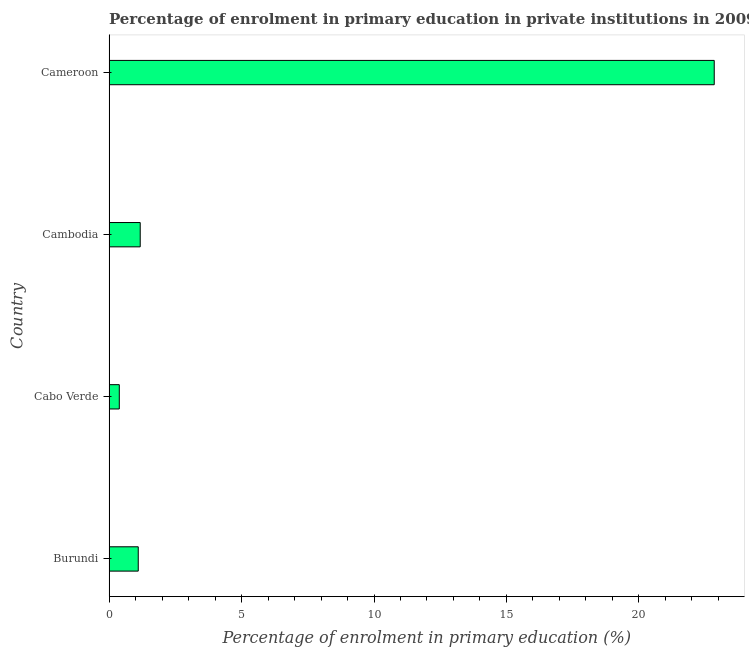Does the graph contain grids?
Ensure brevity in your answer.  No. What is the title of the graph?
Your answer should be very brief. Percentage of enrolment in primary education in private institutions in 2009. What is the label or title of the X-axis?
Keep it short and to the point. Percentage of enrolment in primary education (%). What is the label or title of the Y-axis?
Provide a short and direct response. Country. What is the enrolment percentage in primary education in Burundi?
Your response must be concise. 1.1. Across all countries, what is the maximum enrolment percentage in primary education?
Give a very brief answer. 22.84. Across all countries, what is the minimum enrolment percentage in primary education?
Ensure brevity in your answer.  0.39. In which country was the enrolment percentage in primary education maximum?
Make the answer very short. Cameroon. In which country was the enrolment percentage in primary education minimum?
Keep it short and to the point. Cabo Verde. What is the sum of the enrolment percentage in primary education?
Your response must be concise. 25.51. What is the difference between the enrolment percentage in primary education in Cabo Verde and Cambodia?
Give a very brief answer. -0.79. What is the average enrolment percentage in primary education per country?
Offer a terse response. 6.38. What is the median enrolment percentage in primary education?
Your answer should be compact. 1.14. What is the ratio of the enrolment percentage in primary education in Burundi to that in Cambodia?
Offer a very short reply. 0.94. Is the enrolment percentage in primary education in Burundi less than that in Cameroon?
Offer a very short reply. Yes. Is the difference between the enrolment percentage in primary education in Burundi and Cameroon greater than the difference between any two countries?
Offer a terse response. No. What is the difference between the highest and the second highest enrolment percentage in primary education?
Keep it short and to the point. 21.67. What is the difference between the highest and the lowest enrolment percentage in primary education?
Provide a succinct answer. 22.46. What is the Percentage of enrolment in primary education (%) of Burundi?
Your answer should be very brief. 1.1. What is the Percentage of enrolment in primary education (%) in Cabo Verde?
Your answer should be compact. 0.39. What is the Percentage of enrolment in primary education (%) of Cambodia?
Make the answer very short. 1.18. What is the Percentage of enrolment in primary education (%) of Cameroon?
Give a very brief answer. 22.84. What is the difference between the Percentage of enrolment in primary education (%) in Burundi and Cabo Verde?
Provide a short and direct response. 0.72. What is the difference between the Percentage of enrolment in primary education (%) in Burundi and Cambodia?
Your response must be concise. -0.07. What is the difference between the Percentage of enrolment in primary education (%) in Burundi and Cameroon?
Provide a succinct answer. -21.74. What is the difference between the Percentage of enrolment in primary education (%) in Cabo Verde and Cambodia?
Your response must be concise. -0.79. What is the difference between the Percentage of enrolment in primary education (%) in Cabo Verde and Cameroon?
Provide a short and direct response. -22.46. What is the difference between the Percentage of enrolment in primary education (%) in Cambodia and Cameroon?
Offer a very short reply. -21.67. What is the ratio of the Percentage of enrolment in primary education (%) in Burundi to that in Cabo Verde?
Your response must be concise. 2.85. What is the ratio of the Percentage of enrolment in primary education (%) in Burundi to that in Cambodia?
Provide a succinct answer. 0.94. What is the ratio of the Percentage of enrolment in primary education (%) in Burundi to that in Cameroon?
Your response must be concise. 0.05. What is the ratio of the Percentage of enrolment in primary education (%) in Cabo Verde to that in Cambodia?
Keep it short and to the point. 0.33. What is the ratio of the Percentage of enrolment in primary education (%) in Cabo Verde to that in Cameroon?
Provide a short and direct response. 0.02. What is the ratio of the Percentage of enrolment in primary education (%) in Cambodia to that in Cameroon?
Provide a short and direct response. 0.05. 